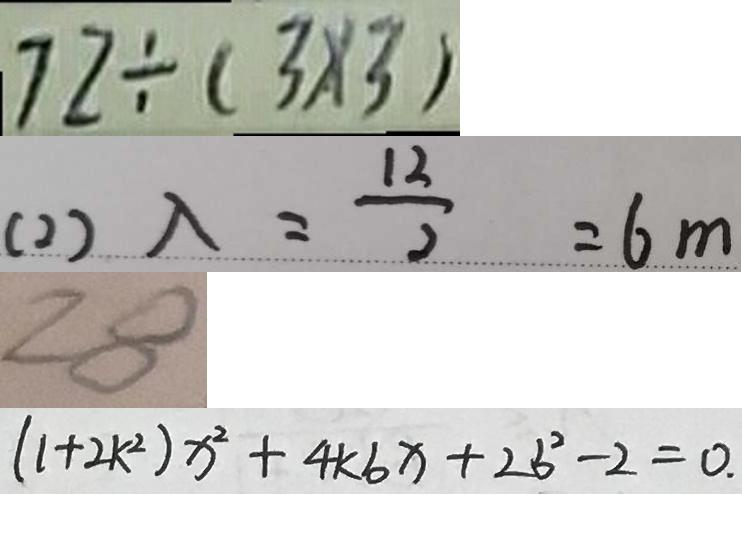Convert formula to latex. <formula><loc_0><loc_0><loc_500><loc_500>7 2 \div ( 3 \times 3 ) 
 ( 2 ) \lambda = \frac { 1 2 } { 2 } = 6 m 
 2 8 
 ( 1 + 2 k ^ { 2 } ) x ^ { 2 } + 4 k b x + 2 b ^ { 2 } - 2 = 0 .</formula> 